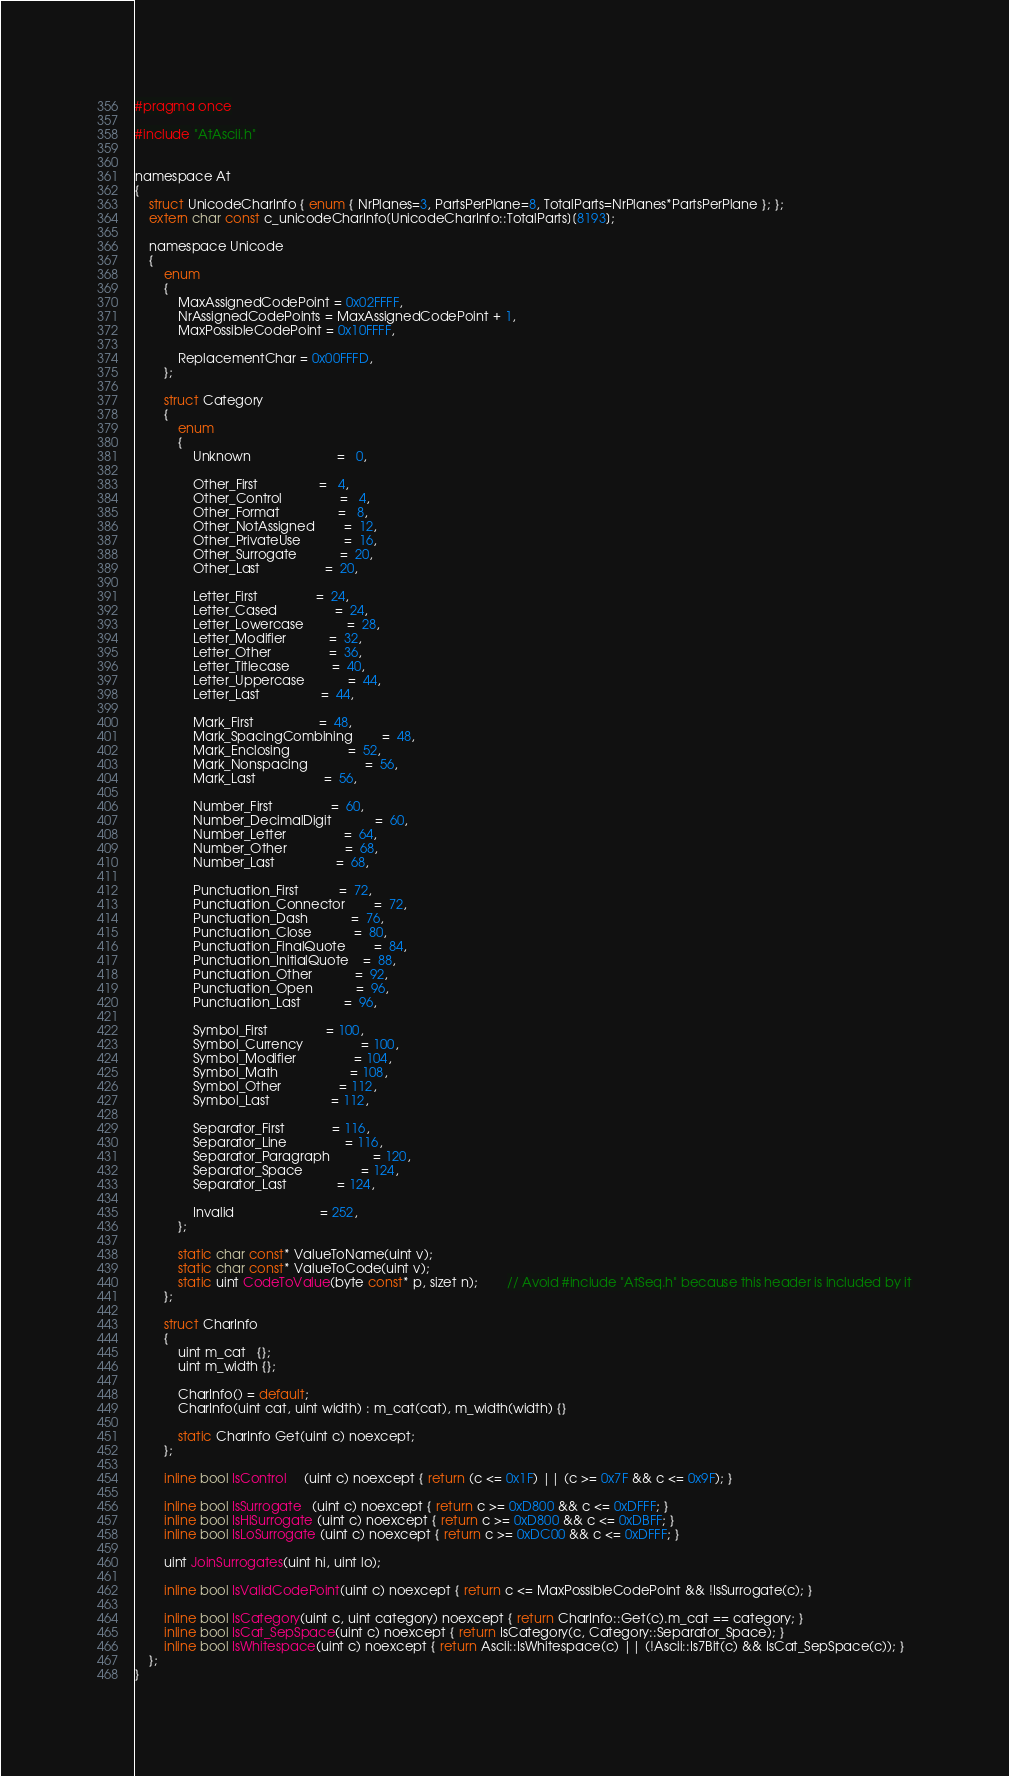<code> <loc_0><loc_0><loc_500><loc_500><_C_>#pragma once

#include "AtAscii.h"


namespace At
{
	struct UnicodeCharInfo { enum { NrPlanes=3, PartsPerPlane=8, TotalParts=NrPlanes*PartsPerPlane }; };
	extern char const c_unicodeCharInfo[UnicodeCharInfo::TotalParts][8193];

	namespace Unicode
	{
		enum
		{
			MaxAssignedCodePoint = 0x02FFFF,
			NrAssignedCodePoints = MaxAssignedCodePoint + 1,
			MaxPossibleCodePoint = 0x10FFFF,

			ReplacementChar = 0x00FFFD,
		};

		struct Category
		{
			enum
			{
				Unknown						=   0,

				Other_First                 =   4,
				Other_Control				=   4,
				Other_Format            	=   8,
				Other_NotAssigned       	=  12,
				Other_PrivateUse        	=  16,
				Other_Surrogate         	=  20,
				Other_Last                  =  20,

				Letter_First                =  24,
				Letter_Cased            	=  24,
				Letter_Lowercase        	=  28,
				Letter_Modifier         	=  32,
				Letter_Other            	=  36,
				Letter_Titlecase			=  40,
				Letter_Uppercase			=  44,
				Letter_Last                 =  44,

				Mark_First                  =  48,
				Mark_SpacingCombining		=  48,
				Mark_Enclosing				=  52,
				Mark_Nonspacing				=  56,
				Mark_Last                   =  56,

				Number_First                =  60,
				Number_DecimalDigit			=  60,
				Number_Letter				=  64,
				Number_Other				=  68,
				Number_Last                 =  68,

				Punctuation_First           =  72,
				Punctuation_Connector		=  72,
				Punctuation_Dash			=  76,
				Punctuation_Close			=  80,
				Punctuation_FinalQuote		=  84,
				Punctuation_InitialQuote	=  88,
				Punctuation_Other			=  92,
				Punctuation_Open			=  96,
				Punctuation_Last            =  96,

				Symbol_First                = 100,
				Symbol_Currency				= 100,
				Symbol_Modifier				= 104,
				Symbol_Math					= 108,
				Symbol_Other				= 112,
				Symbol_Last                 = 112,
				
				Separator_First             = 116,
				Separator_Line				= 116,
				Separator_Paragraph			= 120,
				Separator_Space				= 124,
				Separator_Last              = 124,

				Invalid						= 252,
			};

			static char const* ValueToName(uint v);
			static char const* ValueToCode(uint v);
			static uint CodeToValue(byte const* p, sizet n);		// Avoid #include "AtSeq.h" because this header is included by it
		};

		struct CharInfo
		{
			uint m_cat   {};
			uint m_width {};

			CharInfo() = default;
			CharInfo(uint cat, uint width) : m_cat(cat), m_width(width) {}

			static CharInfo Get(uint c) noexcept;
		};

		inline bool IsControl     (uint c) noexcept { return (c <= 0x1F) || (c >= 0x7F && c <= 0x9F); }
	
		inline bool IsSurrogate   (uint c) noexcept { return c >= 0xD800 && c <= 0xDFFF; }
		inline bool IsHiSurrogate (uint c) noexcept { return c >= 0xD800 && c <= 0xDBFF; }
		inline bool IsLoSurrogate (uint c) noexcept { return c >= 0xDC00 && c <= 0xDFFF; }

		uint JoinSurrogates(uint hi, uint lo);

		inline bool IsValidCodePoint(uint c) noexcept { return c <= MaxPossibleCodePoint && !IsSurrogate(c); }

		inline bool IsCategory(uint c, uint category) noexcept { return CharInfo::Get(c).m_cat == category; }
		inline bool IsCat_SepSpace(uint c) noexcept { return IsCategory(c, Category::Separator_Space); }
		inline bool IsWhitespace(uint c) noexcept { return Ascii::IsWhitespace(c) || (!Ascii::Is7Bit(c) && IsCat_SepSpace(c)); }
	};
}
</code> 